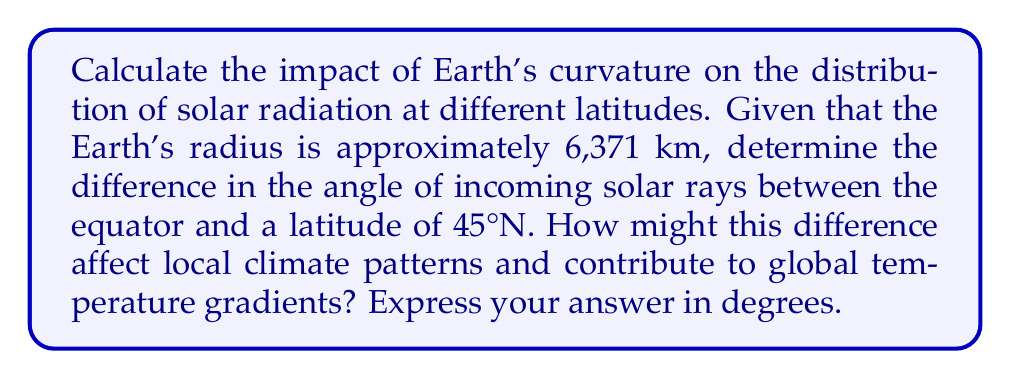Give your solution to this math problem. To solve this problem, we'll follow these steps:

1) First, we need to understand that the Earth's curvature causes solar rays to hit the surface at different angles depending on latitude.

2) At the equator, solar rays are perpendicular to the Earth's surface when the sun is directly overhead. We can represent this as a 90° angle.

3) To find the angle at 45°N latitude, we need to calculate the difference between the tangent line at this latitude and the line from the Earth's center to the sun.

4) We can model this as a right triangle, where:
   - The hypotenuse is the line from the Earth's center to the sun
   - One side is the Earth's radius
   - The other side is the tangent line at 45°N

5) The angle we're looking for is the complement of the latitude angle. At 45°N, this is also 45°.

6) Using trigonometry:

   $$\cos(45°) = \frac{\text{adjacent}}{\text{hypotenuse}} = \frac{R}{R} = 1$$

   Where R is the Earth's radius.

7) The angle of incoming solar rays at 45°N is therefore 90° - 45° = 45°.

8) The difference in the angle of incoming solar rays between the equator and 45°N is:

   $$90° - 45° = 45°$$

9) This difference in angle affects the amount of solar energy received per unit area, contributing to temperature gradients and influencing climate patterns.
Answer: 45° 